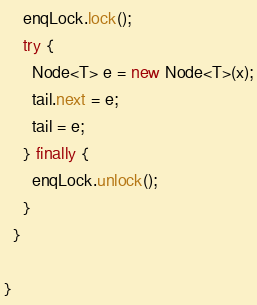Convert code to text. <code><loc_0><loc_0><loc_500><loc_500><_Java_>    enqLock.lock();
    try {
      Node<T> e = new Node<T>(x);
      tail.next = e;
      tail = e;
    } finally {
      enqLock.unlock();
    }
  }

}
</code> 